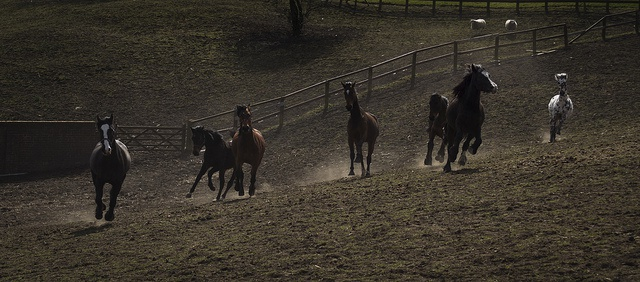Describe the objects in this image and their specific colors. I can see horse in black and gray tones, horse in black, gray, and darkgray tones, horse in black and gray tones, horse in black, gray, and maroon tones, and horse in black and gray tones in this image. 